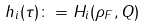Convert formula to latex. <formula><loc_0><loc_0><loc_500><loc_500>h _ { i } ( \tau ) \colon = H _ { i } ( \rho _ { F } , Q )</formula> 